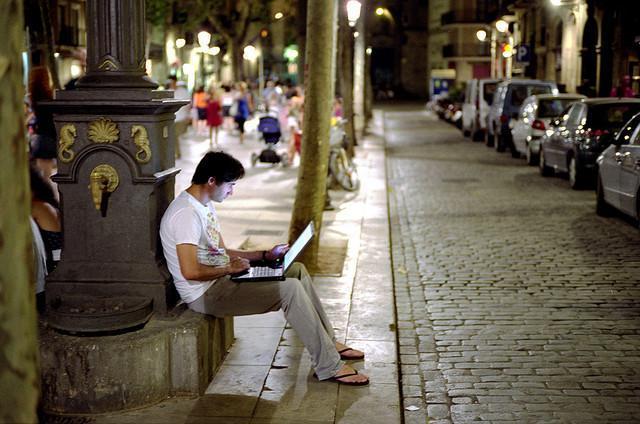How many cars are there?
Give a very brief answer. 4. How many people can you see?
Give a very brief answer. 2. How many clocks are in the shade?
Give a very brief answer. 0. 